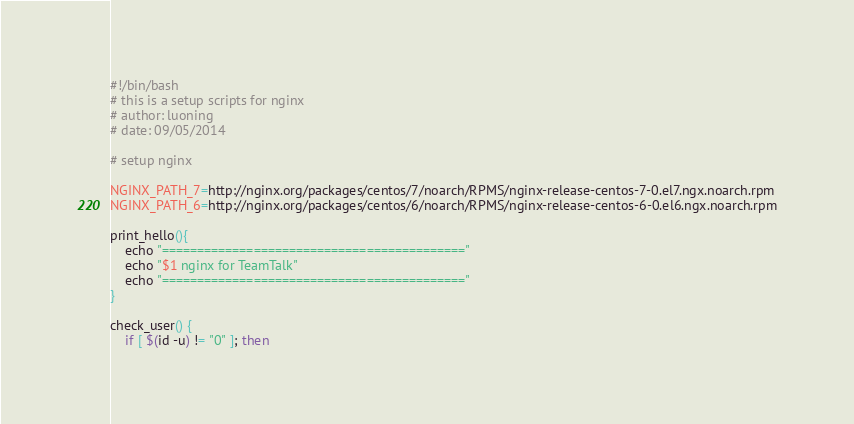<code> <loc_0><loc_0><loc_500><loc_500><_Bash_>#!/bin/bash
# this is a setup scripts for nginx
# author: luoning
# date: 09/05/2014

# setup nginx

NGINX_PATH_7=http://nginx.org/packages/centos/7/noarch/RPMS/nginx-release-centos-7-0.el7.ngx.noarch.rpm
NGINX_PATH_6=http://nginx.org/packages/centos/6/noarch/RPMS/nginx-release-centos-6-0.el6.ngx.noarch.rpm

print_hello(){
	echo "==========================================="
	echo "$1 nginx for TeamTalk"
	echo "==========================================="
}

check_user() {
	if [ $(id -u) != "0" ]; then</code> 